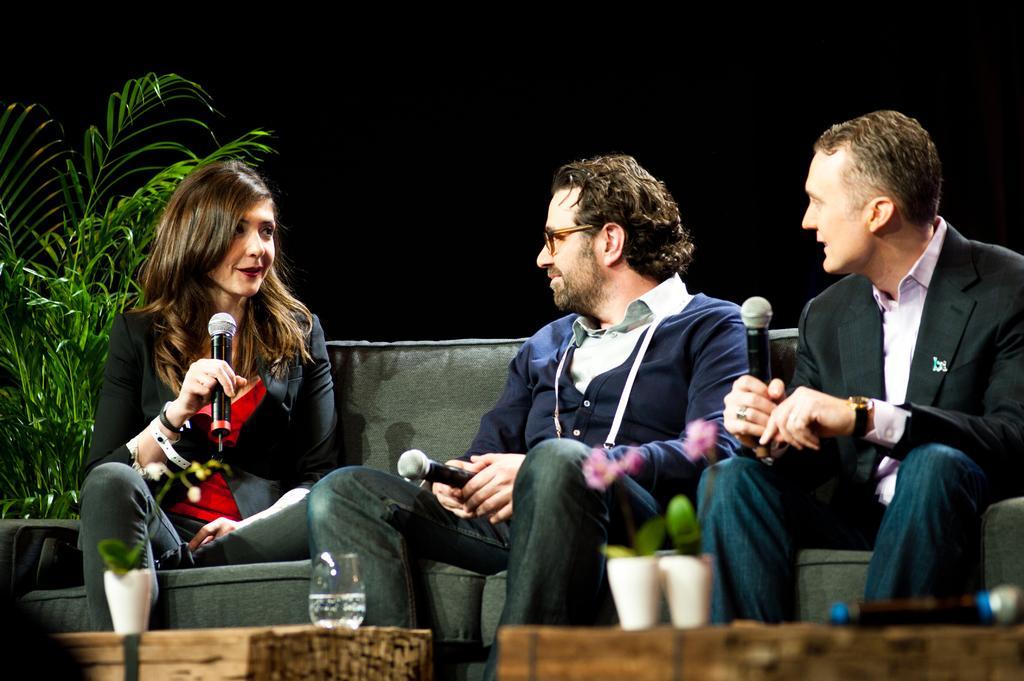Could you give a brief overview of what you see in this image? In a right two boys are sitting and looking at the girl and here a boy is wearing a black color coat and a wrist watch and in the left a woman is sitting on the Sofa holding a microphone. She wear a red color dress and looking at the right behind her there is a plant there is a water glass in front of them. 